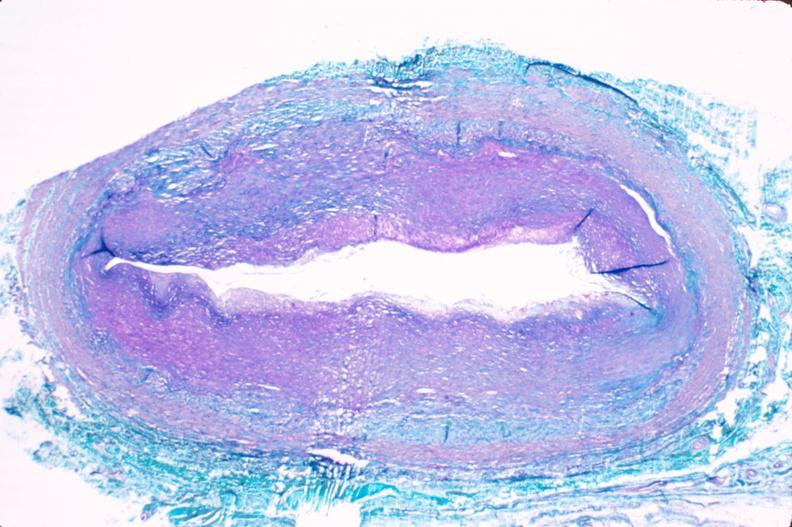what does this image show?
Answer the question using a single word or phrase. Saphenous vein graft sclerosis 